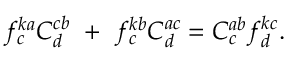<formula> <loc_0><loc_0><loc_500><loc_500>f _ { c } ^ { k a } C _ { d } ^ { c b } + f _ { c } ^ { k b } C _ { d } ^ { a c } = C _ { c } ^ { a b } f _ { d } ^ { k c } .</formula> 